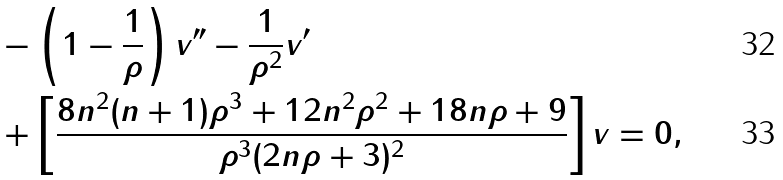Convert formula to latex. <formula><loc_0><loc_0><loc_500><loc_500>& - \left ( 1 - \frac { 1 } { \rho } \right ) v ^ { \prime \prime } - \frac { 1 } { \rho ^ { 2 } } v ^ { \prime } \\ & + \left [ \frac { 8 n ^ { 2 } ( n + 1 ) \rho ^ { 3 } + 1 2 n ^ { 2 } \rho ^ { 2 } + 1 8 n \rho + 9 } { \rho ^ { 3 } ( 2 n \rho + 3 ) ^ { 2 } } \right ] v = 0 ,</formula> 